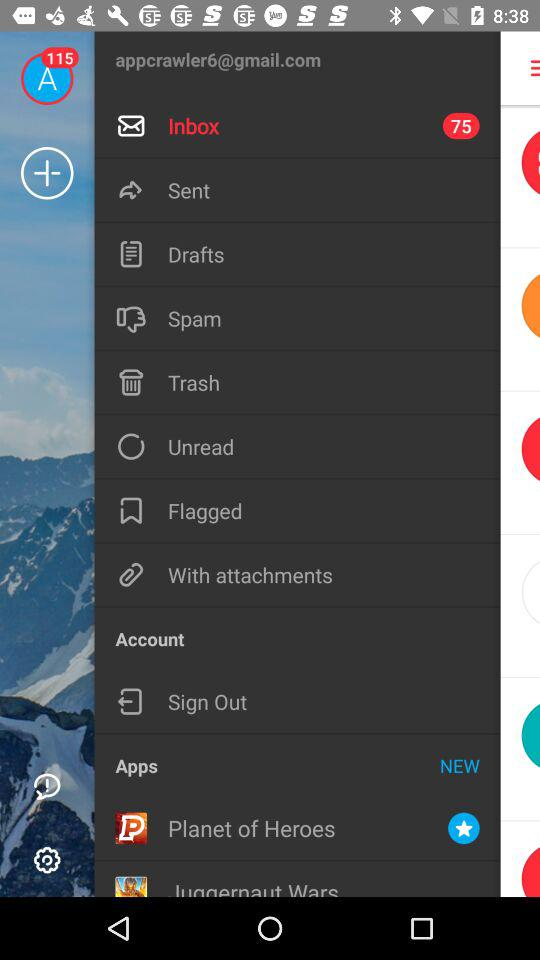What is the email ID? The email ID is appcrawler6@gmail.com. 